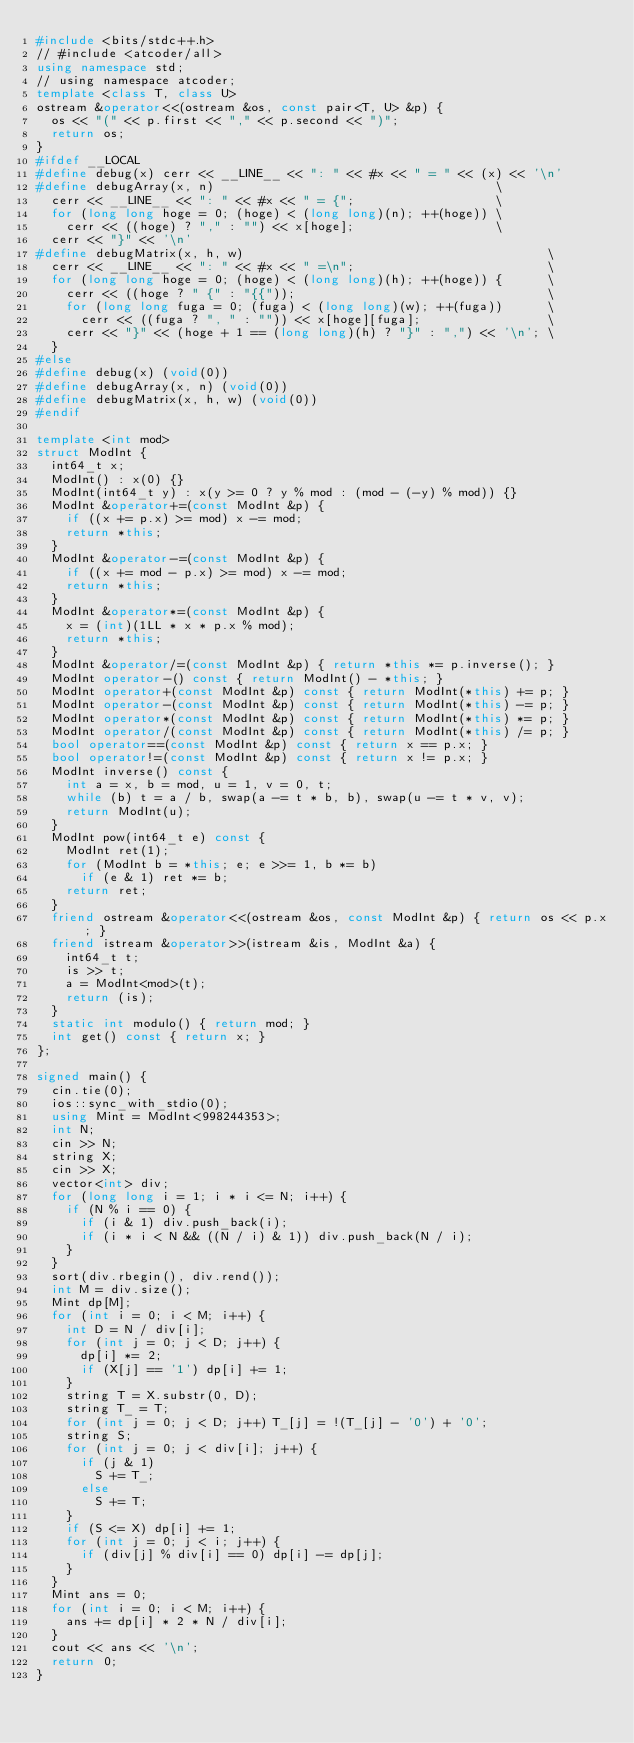Convert code to text. <code><loc_0><loc_0><loc_500><loc_500><_C++_>#include <bits/stdc++.h>
// #include <atcoder/all>
using namespace std;
// using namespace atcoder;
template <class T, class U>
ostream &operator<<(ostream &os, const pair<T, U> &p) {
  os << "(" << p.first << "," << p.second << ")";
  return os;
}
#ifdef __LOCAL
#define debug(x) cerr << __LINE__ << ": " << #x << " = " << (x) << '\n'
#define debugArray(x, n)                                      \
  cerr << __LINE__ << ": " << #x << " = {";                   \
  for (long long hoge = 0; (hoge) < (long long)(n); ++(hoge)) \
    cerr << ((hoge) ? "," : "") << x[hoge];                   \
  cerr << "}" << '\n'
#define debugMatrix(x, h, w)                                         \
  cerr << __LINE__ << ": " << #x << " =\n";                          \
  for (long long hoge = 0; (hoge) < (long long)(h); ++(hoge)) {      \
    cerr << ((hoge ? " {" : "{{"));                                  \
    for (long long fuga = 0; (fuga) < (long long)(w); ++(fuga))      \
      cerr << ((fuga ? ", " : "")) << x[hoge][fuga];                 \
    cerr << "}" << (hoge + 1 == (long long)(h) ? "}" : ",") << '\n'; \
  }
#else
#define debug(x) (void(0))
#define debugArray(x, n) (void(0))
#define debugMatrix(x, h, w) (void(0))
#endif

template <int mod>
struct ModInt {
  int64_t x;
  ModInt() : x(0) {}
  ModInt(int64_t y) : x(y >= 0 ? y % mod : (mod - (-y) % mod)) {}
  ModInt &operator+=(const ModInt &p) {
    if ((x += p.x) >= mod) x -= mod;
    return *this;
  }
  ModInt &operator-=(const ModInt &p) {
    if ((x += mod - p.x) >= mod) x -= mod;
    return *this;
  }
  ModInt &operator*=(const ModInt &p) {
    x = (int)(1LL * x * p.x % mod);
    return *this;
  }
  ModInt &operator/=(const ModInt &p) { return *this *= p.inverse(); }
  ModInt operator-() const { return ModInt() - *this; }
  ModInt operator+(const ModInt &p) const { return ModInt(*this) += p; }
  ModInt operator-(const ModInt &p) const { return ModInt(*this) -= p; }
  ModInt operator*(const ModInt &p) const { return ModInt(*this) *= p; }
  ModInt operator/(const ModInt &p) const { return ModInt(*this) /= p; }
  bool operator==(const ModInt &p) const { return x == p.x; }
  bool operator!=(const ModInt &p) const { return x != p.x; }
  ModInt inverse() const {
    int a = x, b = mod, u = 1, v = 0, t;
    while (b) t = a / b, swap(a -= t * b, b), swap(u -= t * v, v);
    return ModInt(u);
  }
  ModInt pow(int64_t e) const {
    ModInt ret(1);
    for (ModInt b = *this; e; e >>= 1, b *= b)
      if (e & 1) ret *= b;
    return ret;
  }
  friend ostream &operator<<(ostream &os, const ModInt &p) { return os << p.x; }
  friend istream &operator>>(istream &is, ModInt &a) {
    int64_t t;
    is >> t;
    a = ModInt<mod>(t);
    return (is);
  }
  static int modulo() { return mod; }
  int get() const { return x; }
};

signed main() {
  cin.tie(0);
  ios::sync_with_stdio(0);
  using Mint = ModInt<998244353>;
  int N;
  cin >> N;
  string X;
  cin >> X;
  vector<int> div;
  for (long long i = 1; i * i <= N; i++) {
    if (N % i == 0) {
      if (i & 1) div.push_back(i);
      if (i * i < N && ((N / i) & 1)) div.push_back(N / i);
    }
  }
  sort(div.rbegin(), div.rend());
  int M = div.size();
  Mint dp[M];
  for (int i = 0; i < M; i++) {
    int D = N / div[i];
    for (int j = 0; j < D; j++) {
      dp[i] *= 2;
      if (X[j] == '1') dp[i] += 1;
    }
    string T = X.substr(0, D);
    string T_ = T;
    for (int j = 0; j < D; j++) T_[j] = !(T_[j] - '0') + '0';
    string S;
    for (int j = 0; j < div[i]; j++) {
      if (j & 1)
        S += T_;
      else
        S += T;
    }
    if (S <= X) dp[i] += 1;
    for (int j = 0; j < i; j++) {
      if (div[j] % div[i] == 0) dp[i] -= dp[j];
    }
  }
  Mint ans = 0;
  for (int i = 0; i < M; i++) {
    ans += dp[i] * 2 * N / div[i];
  }
  cout << ans << '\n';
  return 0;
}
</code> 